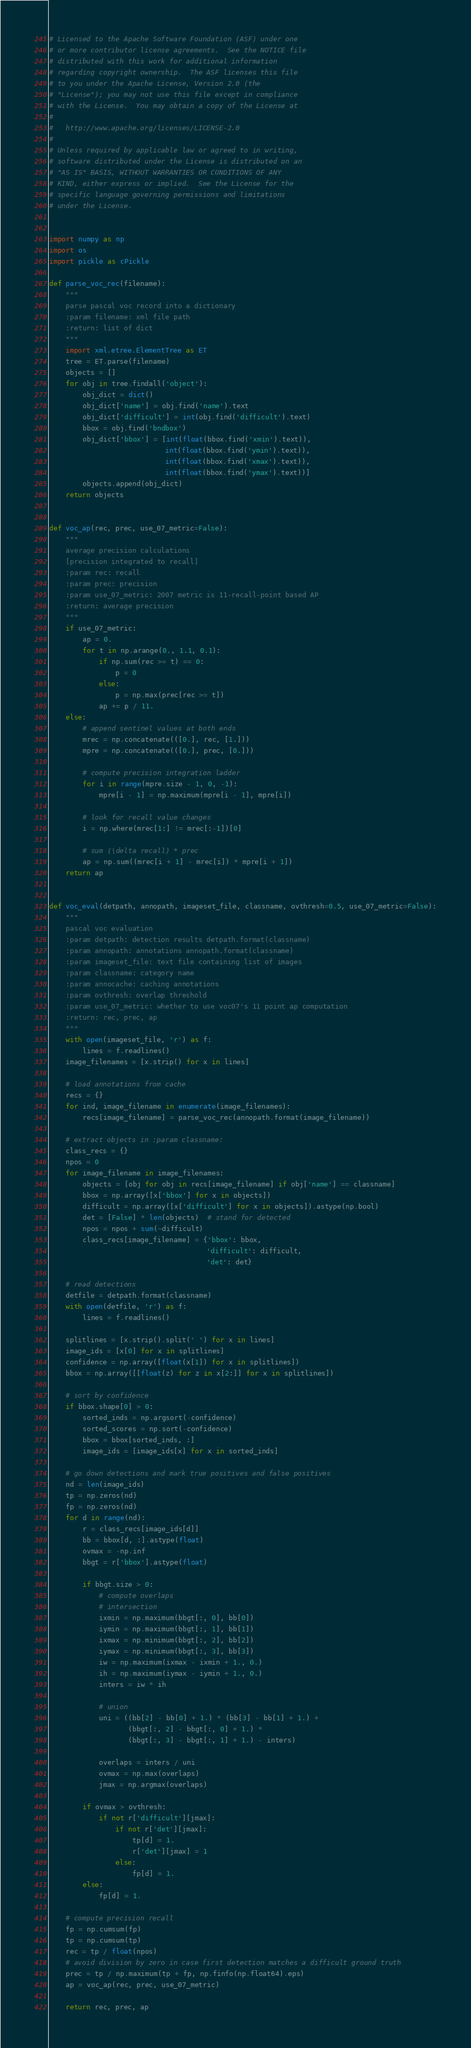Convert code to text. <code><loc_0><loc_0><loc_500><loc_500><_Python_># Licensed to the Apache Software Foundation (ASF) under one
# or more contributor license agreements.  See the NOTICE file
# distributed with this work for additional information
# regarding copyright ownership.  The ASF licenses this file
# to you under the Apache License, Version 2.0 (the
# "License"); you may not use this file except in compliance
# with the License.  You may obtain a copy of the License at
#
#   http://www.apache.org/licenses/LICENSE-2.0
#
# Unless required by applicable law or agreed to in writing,
# software distributed under the License is distributed on an
# "AS IS" BASIS, WITHOUT WARRANTIES OR CONDITIONS OF ANY
# KIND, either express or implied.  See the License for the
# specific language governing permissions and limitations
# under the License.


import numpy as np
import os
import pickle as cPickle

def parse_voc_rec(filename):
    """
    parse pascal voc record into a dictionary
    :param filename: xml file path
    :return: list of dict
    """
    import xml.etree.ElementTree as ET
    tree = ET.parse(filename)
    objects = []
    for obj in tree.findall('object'):
        obj_dict = dict()
        obj_dict['name'] = obj.find('name').text
        obj_dict['difficult'] = int(obj.find('difficult').text)
        bbox = obj.find('bndbox')
        obj_dict['bbox'] = [int(float(bbox.find('xmin').text)),
                            int(float(bbox.find('ymin').text)),
                            int(float(bbox.find('xmax').text)),
                            int(float(bbox.find('ymax').text))]
        objects.append(obj_dict)
    return objects


def voc_ap(rec, prec, use_07_metric=False):
    """
    average precision calculations
    [precision integrated to recall]
    :param rec: recall
    :param prec: precision
    :param use_07_metric: 2007 metric is 11-recall-point based AP
    :return: average precision
    """
    if use_07_metric:
        ap = 0.
        for t in np.arange(0., 1.1, 0.1):
            if np.sum(rec >= t) == 0:
                p = 0
            else:
                p = np.max(prec[rec >= t])
            ap += p / 11.
    else:
        # append sentinel values at both ends
        mrec = np.concatenate(([0.], rec, [1.]))
        mpre = np.concatenate(([0.], prec, [0.]))

        # compute precision integration ladder
        for i in range(mpre.size - 1, 0, -1):
            mpre[i - 1] = np.maximum(mpre[i - 1], mpre[i])

        # look for recall value changes
        i = np.where(mrec[1:] != mrec[:-1])[0]

        # sum (\delta recall) * prec
        ap = np.sum((mrec[i + 1] - mrec[i]) * mpre[i + 1])
    return ap


def voc_eval(detpath, annopath, imageset_file, classname, ovthresh=0.5, use_07_metric=False):
    """
    pascal voc evaluation
    :param detpath: detection results detpath.format(classname)
    :param annopath: annotations annopath.format(classname)
    :param imageset_file: text file containing list of images
    :param classname: category name
    :param annocache: caching annotations
    :param ovthresh: overlap threshold
    :param use_07_metric: whether to use voc07's 11 point ap computation
    :return: rec, prec, ap
    """
    with open(imageset_file, 'r') as f:
        lines = f.readlines()
    image_filenames = [x.strip() for x in lines]

    # load annotations from cache
    recs = {}
    for ind, image_filename in enumerate(image_filenames):
        recs[image_filename] = parse_voc_rec(annopath.format(image_filename))

    # extract objects in :param classname:
    class_recs = {}
    npos = 0
    for image_filename in image_filenames:
        objects = [obj for obj in recs[image_filename] if obj['name'] == classname]
        bbox = np.array([x['bbox'] for x in objects])
        difficult = np.array([x['difficult'] for x in objects]).astype(np.bool)
        det = [False] * len(objects)  # stand for detected
        npos = npos + sum(~difficult)
        class_recs[image_filename] = {'bbox': bbox,
                                      'difficult': difficult,
                                      'det': det}

    # read detections
    detfile = detpath.format(classname)
    with open(detfile, 'r') as f:
        lines = f.readlines()

    splitlines = [x.strip().split(' ') for x in lines]
    image_ids = [x[0] for x in splitlines]
    confidence = np.array([float(x[1]) for x in splitlines])
    bbox = np.array([[float(z) for z in x[2:]] for x in splitlines])

    # sort by confidence
    if bbox.shape[0] > 0:
        sorted_inds = np.argsort(-confidence)
        sorted_scores = np.sort(-confidence)
        bbox = bbox[sorted_inds, :]
        image_ids = [image_ids[x] for x in sorted_inds]

    # go down detections and mark true positives and false positives
    nd = len(image_ids)
    tp = np.zeros(nd)
    fp = np.zeros(nd)
    for d in range(nd):
        r = class_recs[image_ids[d]]
        bb = bbox[d, :].astype(float)
        ovmax = -np.inf
        bbgt = r['bbox'].astype(float)

        if bbgt.size > 0:
            # compute overlaps
            # intersection
            ixmin = np.maximum(bbgt[:, 0], bb[0])
            iymin = np.maximum(bbgt[:, 1], bb[1])
            ixmax = np.minimum(bbgt[:, 2], bb[2])
            iymax = np.minimum(bbgt[:, 3], bb[3])
            iw = np.maximum(ixmax - ixmin + 1., 0.)
            ih = np.maximum(iymax - iymin + 1., 0.)
            inters = iw * ih

            # union
            uni = ((bb[2] - bb[0] + 1.) * (bb[3] - bb[1] + 1.) +
                   (bbgt[:, 2] - bbgt[:, 0] + 1.) *
                   (bbgt[:, 3] - bbgt[:, 1] + 1.) - inters)

            overlaps = inters / uni
            ovmax = np.max(overlaps)
            jmax = np.argmax(overlaps)

        if ovmax > ovthresh:
            if not r['difficult'][jmax]:
                if not r['det'][jmax]:
                    tp[d] = 1.
                    r['det'][jmax] = 1
                else:
                    fp[d] = 1.
        else:
            fp[d] = 1.

    # compute precision recall
    fp = np.cumsum(fp)
    tp = np.cumsum(tp)
    rec = tp / float(npos)
    # avoid division by zero in case first detection matches a difficult ground truth
    prec = tp / np.maximum(tp + fp, np.finfo(np.float64).eps)
    ap = voc_ap(rec, prec, use_07_metric)

    return rec, prec, ap
</code> 